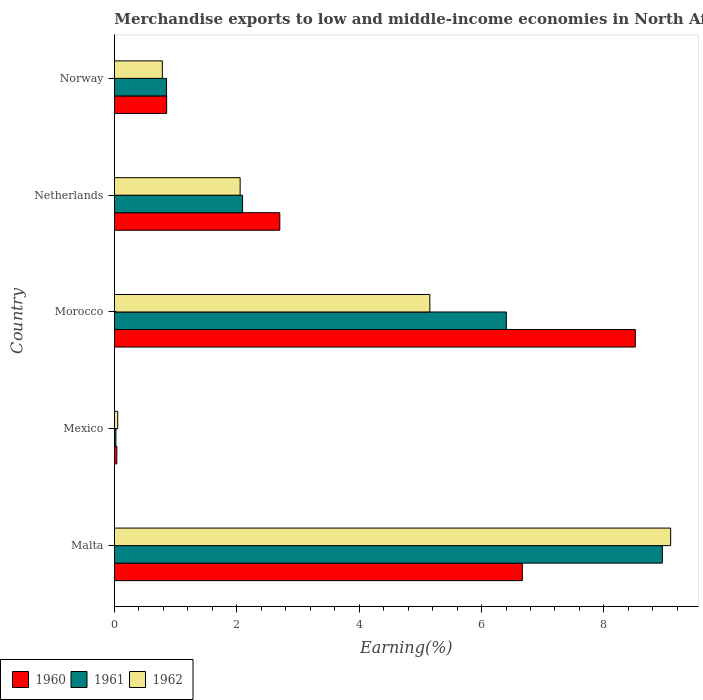How many different coloured bars are there?
Offer a very short reply. 3. How many groups of bars are there?
Provide a short and direct response. 5. Are the number of bars on each tick of the Y-axis equal?
Give a very brief answer. Yes. How many bars are there on the 2nd tick from the top?
Ensure brevity in your answer.  3. What is the label of the 4th group of bars from the top?
Your answer should be very brief. Mexico. In how many cases, is the number of bars for a given country not equal to the number of legend labels?
Give a very brief answer. 0. What is the percentage of amount earned from merchandise exports in 1961 in Malta?
Offer a terse response. 8.96. Across all countries, what is the maximum percentage of amount earned from merchandise exports in 1960?
Your response must be concise. 8.51. Across all countries, what is the minimum percentage of amount earned from merchandise exports in 1961?
Provide a succinct answer. 0.02. In which country was the percentage of amount earned from merchandise exports in 1962 maximum?
Offer a terse response. Malta. In which country was the percentage of amount earned from merchandise exports in 1961 minimum?
Keep it short and to the point. Mexico. What is the total percentage of amount earned from merchandise exports in 1961 in the graph?
Your response must be concise. 18.33. What is the difference between the percentage of amount earned from merchandise exports in 1960 in Mexico and that in Netherlands?
Offer a terse response. -2.66. What is the difference between the percentage of amount earned from merchandise exports in 1962 in Malta and the percentage of amount earned from merchandise exports in 1960 in Mexico?
Make the answer very short. 9.05. What is the average percentage of amount earned from merchandise exports in 1961 per country?
Your answer should be compact. 3.67. What is the difference between the percentage of amount earned from merchandise exports in 1961 and percentage of amount earned from merchandise exports in 1960 in Mexico?
Offer a very short reply. -0.02. In how many countries, is the percentage of amount earned from merchandise exports in 1962 greater than 2.4 %?
Your answer should be compact. 2. What is the ratio of the percentage of amount earned from merchandise exports in 1962 in Mexico to that in Morocco?
Provide a short and direct response. 0.01. What is the difference between the highest and the second highest percentage of amount earned from merchandise exports in 1961?
Your response must be concise. 2.55. What is the difference between the highest and the lowest percentage of amount earned from merchandise exports in 1962?
Make the answer very short. 9.04. Is the sum of the percentage of amount earned from merchandise exports in 1962 in Mexico and Netherlands greater than the maximum percentage of amount earned from merchandise exports in 1960 across all countries?
Offer a terse response. No. What does the 1st bar from the top in Morocco represents?
Your response must be concise. 1962. What does the 1st bar from the bottom in Netherlands represents?
Provide a succinct answer. 1960. Is it the case that in every country, the sum of the percentage of amount earned from merchandise exports in 1960 and percentage of amount earned from merchandise exports in 1962 is greater than the percentage of amount earned from merchandise exports in 1961?
Keep it short and to the point. Yes. What is the difference between two consecutive major ticks on the X-axis?
Offer a very short reply. 2. Where does the legend appear in the graph?
Your answer should be very brief. Bottom left. How are the legend labels stacked?
Provide a succinct answer. Horizontal. What is the title of the graph?
Keep it short and to the point. Merchandise exports to low and middle-income economies in North Africa. What is the label or title of the X-axis?
Provide a short and direct response. Earning(%). What is the Earning(%) of 1960 in Malta?
Your answer should be compact. 6.67. What is the Earning(%) of 1961 in Malta?
Offer a very short reply. 8.96. What is the Earning(%) in 1962 in Malta?
Ensure brevity in your answer.  9.09. What is the Earning(%) in 1960 in Mexico?
Offer a very short reply. 0.04. What is the Earning(%) of 1961 in Mexico?
Ensure brevity in your answer.  0.02. What is the Earning(%) of 1962 in Mexico?
Your response must be concise. 0.05. What is the Earning(%) of 1960 in Morocco?
Offer a very short reply. 8.51. What is the Earning(%) in 1961 in Morocco?
Your answer should be compact. 6.41. What is the Earning(%) of 1962 in Morocco?
Provide a succinct answer. 5.15. What is the Earning(%) of 1960 in Netherlands?
Offer a very short reply. 2.7. What is the Earning(%) of 1961 in Netherlands?
Provide a short and direct response. 2.09. What is the Earning(%) in 1962 in Netherlands?
Offer a very short reply. 2.05. What is the Earning(%) in 1960 in Norway?
Make the answer very short. 0.85. What is the Earning(%) in 1961 in Norway?
Ensure brevity in your answer.  0.85. What is the Earning(%) in 1962 in Norway?
Your answer should be very brief. 0.78. Across all countries, what is the maximum Earning(%) in 1960?
Provide a short and direct response. 8.51. Across all countries, what is the maximum Earning(%) of 1961?
Make the answer very short. 8.96. Across all countries, what is the maximum Earning(%) of 1962?
Make the answer very short. 9.09. Across all countries, what is the minimum Earning(%) of 1960?
Keep it short and to the point. 0.04. Across all countries, what is the minimum Earning(%) in 1961?
Provide a short and direct response. 0.02. Across all countries, what is the minimum Earning(%) in 1962?
Provide a succinct answer. 0.05. What is the total Earning(%) in 1960 in the graph?
Your response must be concise. 18.78. What is the total Earning(%) of 1961 in the graph?
Keep it short and to the point. 18.33. What is the total Earning(%) of 1962 in the graph?
Keep it short and to the point. 17.14. What is the difference between the Earning(%) of 1960 in Malta and that in Mexico?
Provide a short and direct response. 6.63. What is the difference between the Earning(%) in 1961 in Malta and that in Mexico?
Make the answer very short. 8.93. What is the difference between the Earning(%) of 1962 in Malta and that in Mexico?
Make the answer very short. 9.04. What is the difference between the Earning(%) in 1960 in Malta and that in Morocco?
Offer a terse response. -1.85. What is the difference between the Earning(%) in 1961 in Malta and that in Morocco?
Make the answer very short. 2.55. What is the difference between the Earning(%) in 1962 in Malta and that in Morocco?
Make the answer very short. 3.94. What is the difference between the Earning(%) of 1960 in Malta and that in Netherlands?
Offer a very short reply. 3.96. What is the difference between the Earning(%) of 1961 in Malta and that in Netherlands?
Your answer should be very brief. 6.86. What is the difference between the Earning(%) in 1962 in Malta and that in Netherlands?
Make the answer very short. 7.04. What is the difference between the Earning(%) of 1960 in Malta and that in Norway?
Offer a very short reply. 5.81. What is the difference between the Earning(%) of 1961 in Malta and that in Norway?
Make the answer very short. 8.1. What is the difference between the Earning(%) in 1962 in Malta and that in Norway?
Your answer should be compact. 8.31. What is the difference between the Earning(%) of 1960 in Mexico and that in Morocco?
Ensure brevity in your answer.  -8.47. What is the difference between the Earning(%) in 1961 in Mexico and that in Morocco?
Offer a terse response. -6.38. What is the difference between the Earning(%) of 1962 in Mexico and that in Morocco?
Provide a succinct answer. -5.1. What is the difference between the Earning(%) of 1960 in Mexico and that in Netherlands?
Your answer should be compact. -2.66. What is the difference between the Earning(%) in 1961 in Mexico and that in Netherlands?
Offer a very short reply. -2.07. What is the difference between the Earning(%) in 1962 in Mexico and that in Netherlands?
Give a very brief answer. -2. What is the difference between the Earning(%) of 1960 in Mexico and that in Norway?
Provide a succinct answer. -0.81. What is the difference between the Earning(%) in 1961 in Mexico and that in Norway?
Keep it short and to the point. -0.83. What is the difference between the Earning(%) of 1962 in Mexico and that in Norway?
Keep it short and to the point. -0.73. What is the difference between the Earning(%) in 1960 in Morocco and that in Netherlands?
Offer a very short reply. 5.81. What is the difference between the Earning(%) in 1961 in Morocco and that in Netherlands?
Make the answer very short. 4.31. What is the difference between the Earning(%) of 1962 in Morocco and that in Netherlands?
Your answer should be compact. 3.1. What is the difference between the Earning(%) in 1960 in Morocco and that in Norway?
Provide a succinct answer. 7.66. What is the difference between the Earning(%) in 1961 in Morocco and that in Norway?
Make the answer very short. 5.55. What is the difference between the Earning(%) of 1962 in Morocco and that in Norway?
Ensure brevity in your answer.  4.37. What is the difference between the Earning(%) of 1960 in Netherlands and that in Norway?
Provide a short and direct response. 1.85. What is the difference between the Earning(%) in 1961 in Netherlands and that in Norway?
Provide a short and direct response. 1.24. What is the difference between the Earning(%) in 1962 in Netherlands and that in Norway?
Give a very brief answer. 1.27. What is the difference between the Earning(%) in 1960 in Malta and the Earning(%) in 1961 in Mexico?
Your response must be concise. 6.64. What is the difference between the Earning(%) of 1960 in Malta and the Earning(%) of 1962 in Mexico?
Ensure brevity in your answer.  6.61. What is the difference between the Earning(%) of 1961 in Malta and the Earning(%) of 1962 in Mexico?
Ensure brevity in your answer.  8.9. What is the difference between the Earning(%) of 1960 in Malta and the Earning(%) of 1961 in Morocco?
Provide a short and direct response. 0.26. What is the difference between the Earning(%) in 1960 in Malta and the Earning(%) in 1962 in Morocco?
Provide a succinct answer. 1.51. What is the difference between the Earning(%) in 1961 in Malta and the Earning(%) in 1962 in Morocco?
Your response must be concise. 3.8. What is the difference between the Earning(%) in 1960 in Malta and the Earning(%) in 1961 in Netherlands?
Offer a terse response. 4.57. What is the difference between the Earning(%) of 1960 in Malta and the Earning(%) of 1962 in Netherlands?
Keep it short and to the point. 4.61. What is the difference between the Earning(%) of 1961 in Malta and the Earning(%) of 1962 in Netherlands?
Your answer should be very brief. 6.9. What is the difference between the Earning(%) in 1960 in Malta and the Earning(%) in 1961 in Norway?
Give a very brief answer. 5.81. What is the difference between the Earning(%) of 1960 in Malta and the Earning(%) of 1962 in Norway?
Make the answer very short. 5.88. What is the difference between the Earning(%) in 1961 in Malta and the Earning(%) in 1962 in Norway?
Ensure brevity in your answer.  8.17. What is the difference between the Earning(%) in 1960 in Mexico and the Earning(%) in 1961 in Morocco?
Provide a short and direct response. -6.37. What is the difference between the Earning(%) in 1960 in Mexico and the Earning(%) in 1962 in Morocco?
Offer a very short reply. -5.12. What is the difference between the Earning(%) in 1961 in Mexico and the Earning(%) in 1962 in Morocco?
Provide a succinct answer. -5.13. What is the difference between the Earning(%) in 1960 in Mexico and the Earning(%) in 1961 in Netherlands?
Ensure brevity in your answer.  -2.05. What is the difference between the Earning(%) of 1960 in Mexico and the Earning(%) of 1962 in Netherlands?
Your answer should be compact. -2.02. What is the difference between the Earning(%) in 1961 in Mexico and the Earning(%) in 1962 in Netherlands?
Your answer should be very brief. -2.03. What is the difference between the Earning(%) of 1960 in Mexico and the Earning(%) of 1961 in Norway?
Make the answer very short. -0.81. What is the difference between the Earning(%) in 1960 in Mexico and the Earning(%) in 1962 in Norway?
Your response must be concise. -0.74. What is the difference between the Earning(%) in 1961 in Mexico and the Earning(%) in 1962 in Norway?
Your answer should be compact. -0.76. What is the difference between the Earning(%) of 1960 in Morocco and the Earning(%) of 1961 in Netherlands?
Your answer should be very brief. 6.42. What is the difference between the Earning(%) in 1960 in Morocco and the Earning(%) in 1962 in Netherlands?
Keep it short and to the point. 6.46. What is the difference between the Earning(%) in 1961 in Morocco and the Earning(%) in 1962 in Netherlands?
Keep it short and to the point. 4.35. What is the difference between the Earning(%) of 1960 in Morocco and the Earning(%) of 1961 in Norway?
Your answer should be very brief. 7.66. What is the difference between the Earning(%) in 1960 in Morocco and the Earning(%) in 1962 in Norway?
Give a very brief answer. 7.73. What is the difference between the Earning(%) of 1961 in Morocco and the Earning(%) of 1962 in Norway?
Your answer should be compact. 5.62. What is the difference between the Earning(%) of 1960 in Netherlands and the Earning(%) of 1961 in Norway?
Provide a short and direct response. 1.85. What is the difference between the Earning(%) in 1960 in Netherlands and the Earning(%) in 1962 in Norway?
Offer a terse response. 1.92. What is the difference between the Earning(%) of 1961 in Netherlands and the Earning(%) of 1962 in Norway?
Ensure brevity in your answer.  1.31. What is the average Earning(%) of 1960 per country?
Provide a short and direct response. 3.76. What is the average Earning(%) in 1961 per country?
Offer a terse response. 3.67. What is the average Earning(%) in 1962 per country?
Provide a short and direct response. 3.43. What is the difference between the Earning(%) of 1960 and Earning(%) of 1961 in Malta?
Make the answer very short. -2.29. What is the difference between the Earning(%) of 1960 and Earning(%) of 1962 in Malta?
Offer a very short reply. -2.42. What is the difference between the Earning(%) of 1961 and Earning(%) of 1962 in Malta?
Your answer should be compact. -0.14. What is the difference between the Earning(%) of 1960 and Earning(%) of 1961 in Mexico?
Provide a succinct answer. 0.01. What is the difference between the Earning(%) in 1960 and Earning(%) in 1962 in Mexico?
Offer a terse response. -0.01. What is the difference between the Earning(%) of 1961 and Earning(%) of 1962 in Mexico?
Your answer should be very brief. -0.03. What is the difference between the Earning(%) in 1960 and Earning(%) in 1961 in Morocco?
Your answer should be very brief. 2.11. What is the difference between the Earning(%) of 1960 and Earning(%) of 1962 in Morocco?
Give a very brief answer. 3.36. What is the difference between the Earning(%) in 1961 and Earning(%) in 1962 in Morocco?
Give a very brief answer. 1.25. What is the difference between the Earning(%) of 1960 and Earning(%) of 1961 in Netherlands?
Provide a short and direct response. 0.61. What is the difference between the Earning(%) of 1960 and Earning(%) of 1962 in Netherlands?
Provide a succinct answer. 0.65. What is the difference between the Earning(%) of 1961 and Earning(%) of 1962 in Netherlands?
Ensure brevity in your answer.  0.04. What is the difference between the Earning(%) of 1960 and Earning(%) of 1961 in Norway?
Make the answer very short. 0. What is the difference between the Earning(%) in 1960 and Earning(%) in 1962 in Norway?
Give a very brief answer. 0.07. What is the difference between the Earning(%) of 1961 and Earning(%) of 1962 in Norway?
Offer a very short reply. 0.07. What is the ratio of the Earning(%) in 1960 in Malta to that in Mexico?
Your answer should be very brief. 169.87. What is the ratio of the Earning(%) in 1961 in Malta to that in Mexico?
Offer a terse response. 369.67. What is the ratio of the Earning(%) of 1962 in Malta to that in Mexico?
Provide a succinct answer. 169.22. What is the ratio of the Earning(%) of 1960 in Malta to that in Morocco?
Your answer should be very brief. 0.78. What is the ratio of the Earning(%) in 1961 in Malta to that in Morocco?
Make the answer very short. 1.4. What is the ratio of the Earning(%) of 1962 in Malta to that in Morocco?
Provide a short and direct response. 1.76. What is the ratio of the Earning(%) of 1960 in Malta to that in Netherlands?
Your response must be concise. 2.47. What is the ratio of the Earning(%) in 1961 in Malta to that in Netherlands?
Offer a terse response. 4.28. What is the ratio of the Earning(%) in 1962 in Malta to that in Netherlands?
Keep it short and to the point. 4.42. What is the ratio of the Earning(%) in 1960 in Malta to that in Norway?
Offer a very short reply. 7.81. What is the ratio of the Earning(%) in 1961 in Malta to that in Norway?
Your response must be concise. 10.51. What is the ratio of the Earning(%) in 1962 in Malta to that in Norway?
Your response must be concise. 11.61. What is the ratio of the Earning(%) in 1960 in Mexico to that in Morocco?
Your response must be concise. 0. What is the ratio of the Earning(%) of 1961 in Mexico to that in Morocco?
Ensure brevity in your answer.  0. What is the ratio of the Earning(%) in 1962 in Mexico to that in Morocco?
Provide a short and direct response. 0.01. What is the ratio of the Earning(%) in 1960 in Mexico to that in Netherlands?
Keep it short and to the point. 0.01. What is the ratio of the Earning(%) in 1961 in Mexico to that in Netherlands?
Ensure brevity in your answer.  0.01. What is the ratio of the Earning(%) in 1962 in Mexico to that in Netherlands?
Provide a short and direct response. 0.03. What is the ratio of the Earning(%) in 1960 in Mexico to that in Norway?
Your answer should be compact. 0.05. What is the ratio of the Earning(%) of 1961 in Mexico to that in Norway?
Offer a terse response. 0.03. What is the ratio of the Earning(%) in 1962 in Mexico to that in Norway?
Your response must be concise. 0.07. What is the ratio of the Earning(%) in 1960 in Morocco to that in Netherlands?
Your response must be concise. 3.15. What is the ratio of the Earning(%) in 1961 in Morocco to that in Netherlands?
Make the answer very short. 3.06. What is the ratio of the Earning(%) in 1962 in Morocco to that in Netherlands?
Ensure brevity in your answer.  2.51. What is the ratio of the Earning(%) in 1960 in Morocco to that in Norway?
Your response must be concise. 9.97. What is the ratio of the Earning(%) in 1961 in Morocco to that in Norway?
Ensure brevity in your answer.  7.52. What is the ratio of the Earning(%) in 1962 in Morocco to that in Norway?
Give a very brief answer. 6.58. What is the ratio of the Earning(%) of 1960 in Netherlands to that in Norway?
Offer a terse response. 3.17. What is the ratio of the Earning(%) of 1961 in Netherlands to that in Norway?
Offer a very short reply. 2.46. What is the ratio of the Earning(%) in 1962 in Netherlands to that in Norway?
Your response must be concise. 2.62. What is the difference between the highest and the second highest Earning(%) in 1960?
Provide a short and direct response. 1.85. What is the difference between the highest and the second highest Earning(%) in 1961?
Provide a succinct answer. 2.55. What is the difference between the highest and the second highest Earning(%) in 1962?
Provide a short and direct response. 3.94. What is the difference between the highest and the lowest Earning(%) of 1960?
Provide a succinct answer. 8.47. What is the difference between the highest and the lowest Earning(%) of 1961?
Provide a short and direct response. 8.93. What is the difference between the highest and the lowest Earning(%) of 1962?
Ensure brevity in your answer.  9.04. 